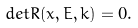Convert formula to latex. <formula><loc_0><loc_0><loc_500><loc_500>d e t R ( x , E , k ) = 0 .</formula> 